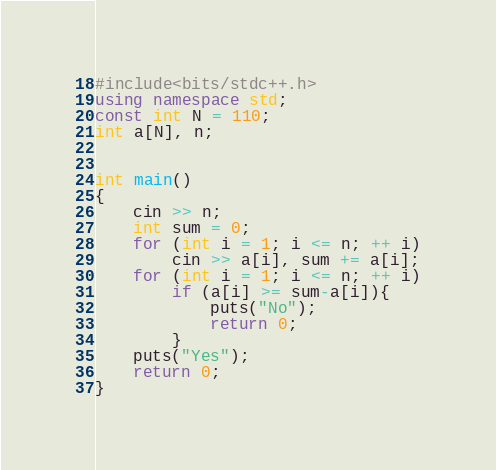Convert code to text. <code><loc_0><loc_0><loc_500><loc_500><_C++_>#include<bits/stdc++.h>
using namespace std;
const int N = 110;
int a[N], n;


int main()
{
	cin >> n;
	int sum = 0;
	for (int i = 1; i <= n; ++ i)
		cin >> a[i], sum += a[i];
	for (int i = 1; i <= n; ++ i)
		if (a[i] >= sum-a[i]){
			puts("No");
			return 0;
		}
	puts("Yes");
	return 0;
}</code> 